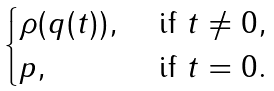<formula> <loc_0><loc_0><loc_500><loc_500>\begin{cases} \rho ( q ( t ) ) , & \text { if } t \neq 0 , \\ p , & \text { if } t = 0 . \end{cases}</formula> 